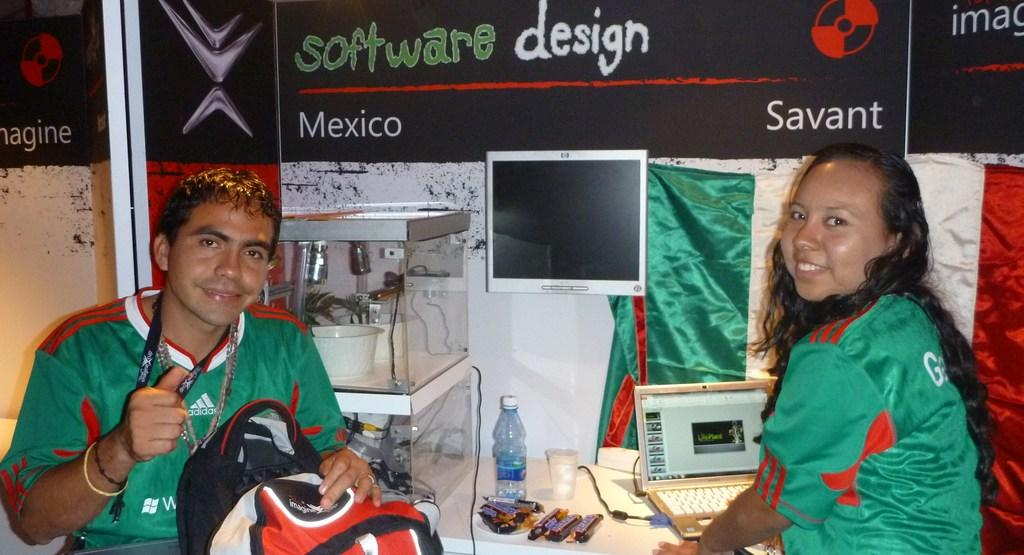<image>
Create a compact narrative representing the image presented. A boy and girl are sitting at a booth with a laptop under a sign that says software design. 